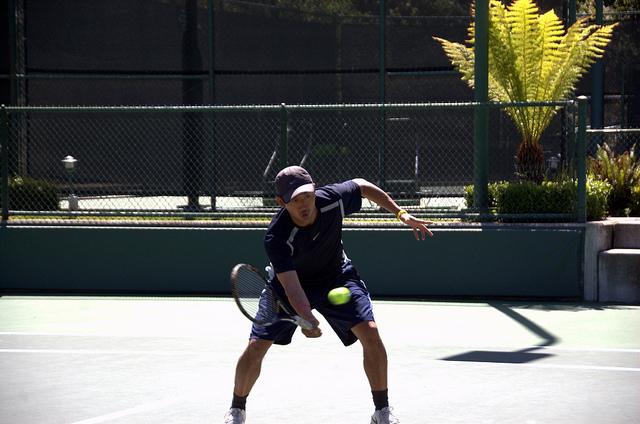Is the man about to hit the ball?
Quick response, please. Yes. Is there a palm tree in the background?
Be succinct. Yes. What is he playing?
Short answer required. Tennis. 